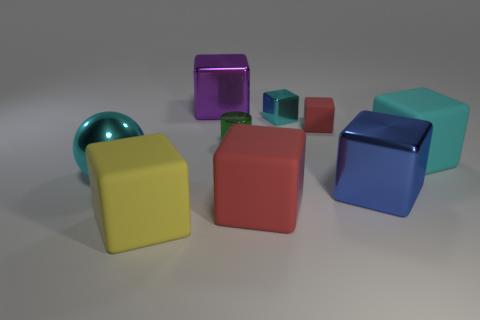Does the cube left of the big purple metallic thing have the same material as the block behind the tiny metal cube?
Make the answer very short. No. What number of things are matte blocks behind the large cyan rubber block or large yellow things?
Provide a short and direct response. 2. What number of things are either small red rubber things or matte cubes right of the small red rubber block?
Your answer should be compact. 2. What number of purple cubes have the same size as the cyan ball?
Give a very brief answer. 1. Is the number of big metal things on the left side of the tiny red matte block less than the number of small cubes that are on the left side of the green metallic cylinder?
Make the answer very short. No. How many matte things are big blue things or small objects?
Your response must be concise. 1. What shape is the tiny red thing?
Your answer should be compact. Cube. What is the material of the blue object that is the same size as the metallic ball?
Keep it short and to the point. Metal. How many big things are either matte cubes or gray matte cylinders?
Make the answer very short. 3. Are any large cyan metal objects visible?
Your response must be concise. Yes. 